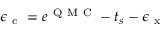<formula> <loc_0><loc_0><loc_500><loc_500>\epsilon _ { c } = e ^ { Q M C } - t _ { s } - \epsilon _ { x }</formula> 